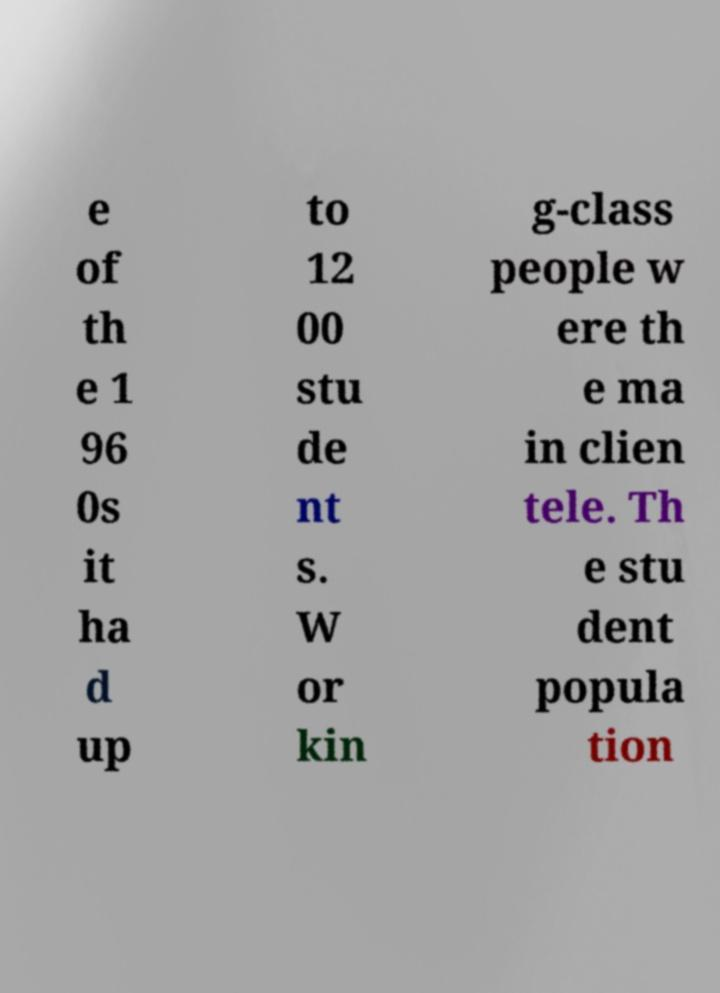There's text embedded in this image that I need extracted. Can you transcribe it verbatim? e of th e 1 96 0s it ha d up to 12 00 stu de nt s. W or kin g-class people w ere th e ma in clien tele. Th e stu dent popula tion 